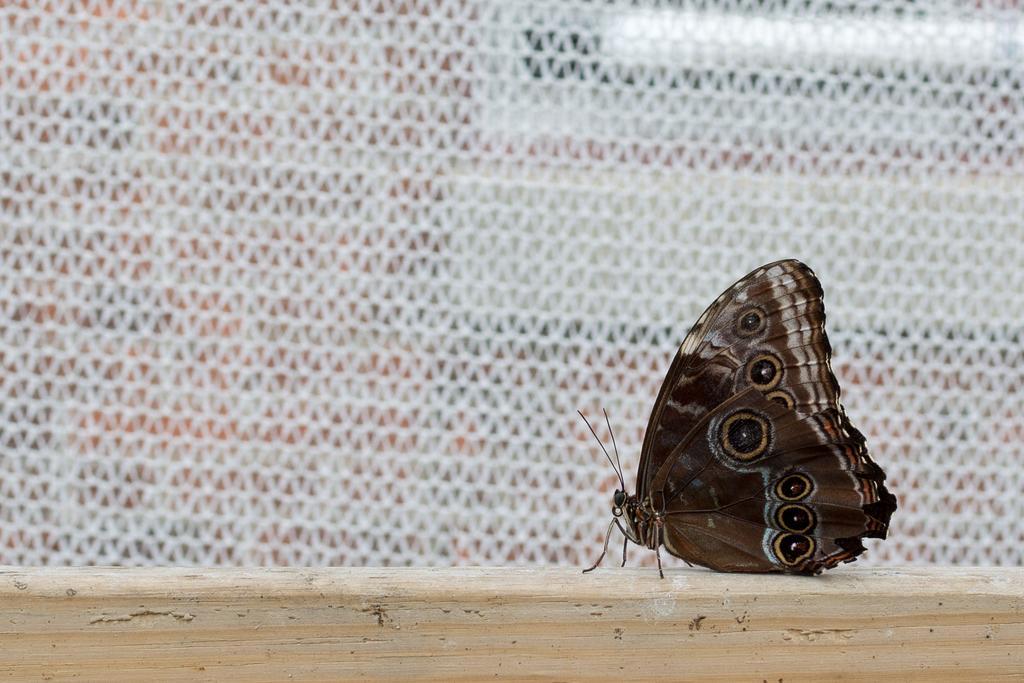How would you summarize this image in a sentence or two? In the foreground of the image there is a butterfly on the wooden surface. In the background of the image there is net. 